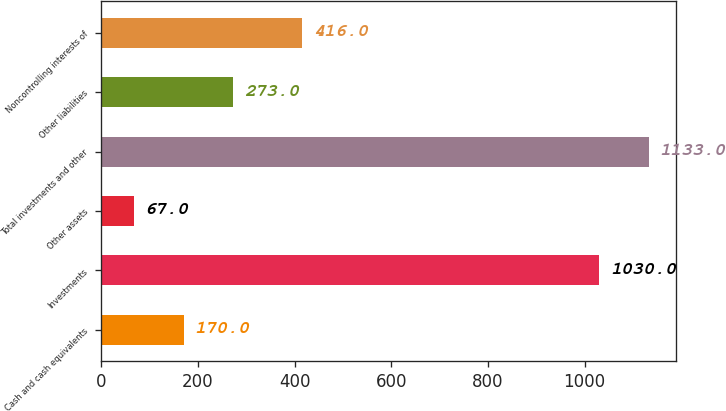<chart> <loc_0><loc_0><loc_500><loc_500><bar_chart><fcel>Cash and cash equivalents<fcel>Investments<fcel>Other assets<fcel>Total investments and other<fcel>Other liabilities<fcel>Noncontrolling interests of<nl><fcel>170<fcel>1030<fcel>67<fcel>1133<fcel>273<fcel>416<nl></chart> 